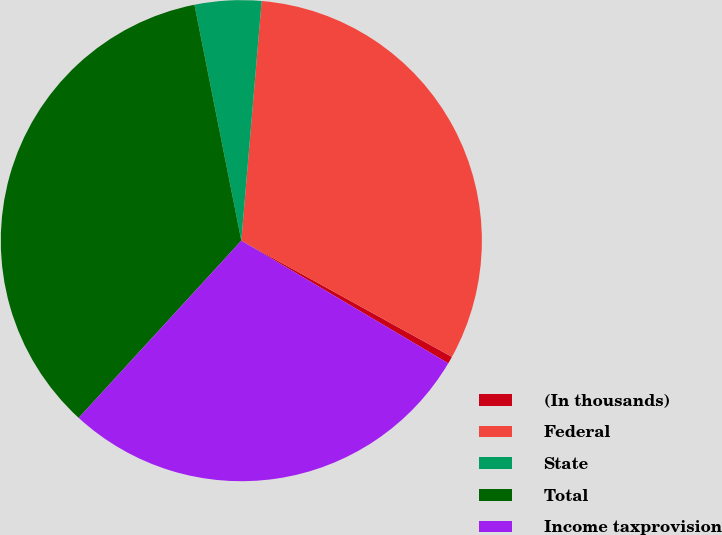Convert chart. <chart><loc_0><loc_0><loc_500><loc_500><pie_chart><fcel>(In thousands)<fcel>Federal<fcel>State<fcel>Total<fcel>Income taxprovision<nl><fcel>0.49%<fcel>31.68%<fcel>4.47%<fcel>35.06%<fcel>28.3%<nl></chart> 